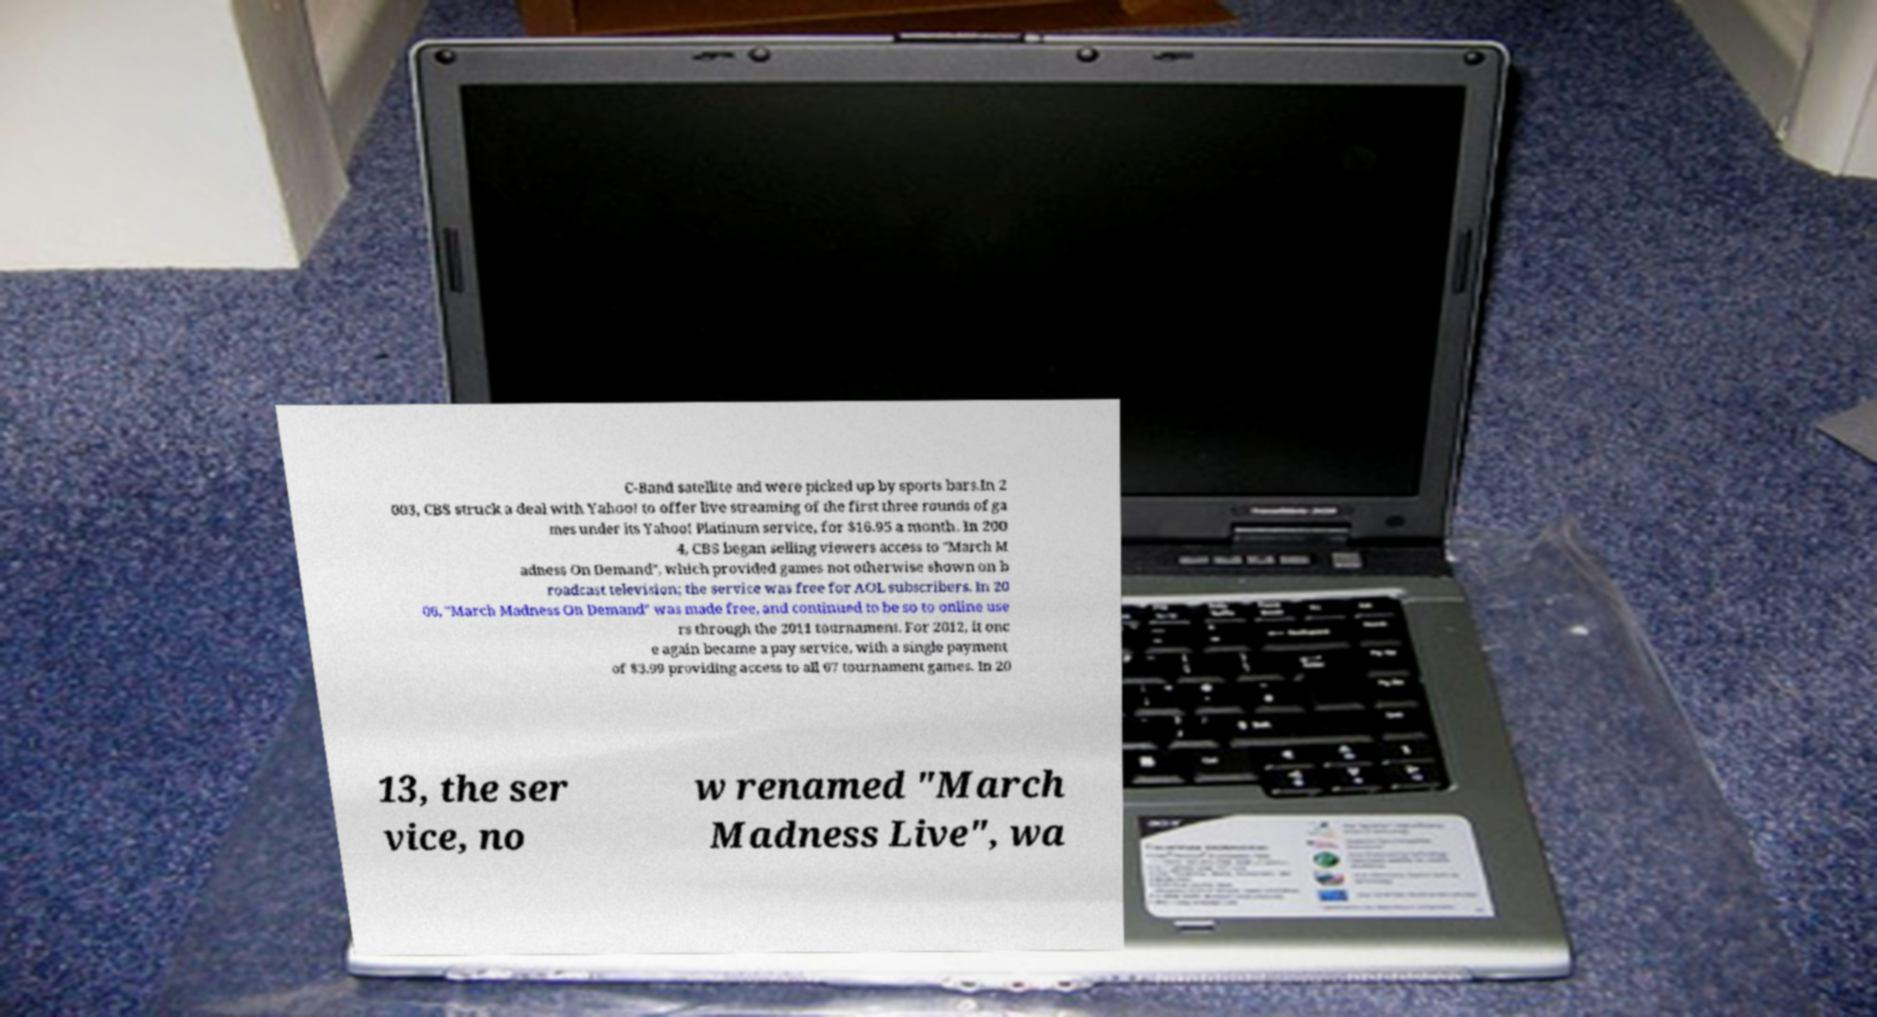Please identify and transcribe the text found in this image. C-Band satellite and were picked up by sports bars.In 2 003, CBS struck a deal with Yahoo! to offer live streaming of the first three rounds of ga mes under its Yahoo! Platinum service, for $16.95 a month. In 200 4, CBS began selling viewers access to "March M adness On Demand", which provided games not otherwise shown on b roadcast television; the service was free for AOL subscribers. In 20 06, "March Madness On Demand" was made free, and continued to be so to online use rs through the 2011 tournament. For 2012, it onc e again became a pay service, with a single payment of $3.99 providing access to all 67 tournament games. In 20 13, the ser vice, no w renamed "March Madness Live", wa 